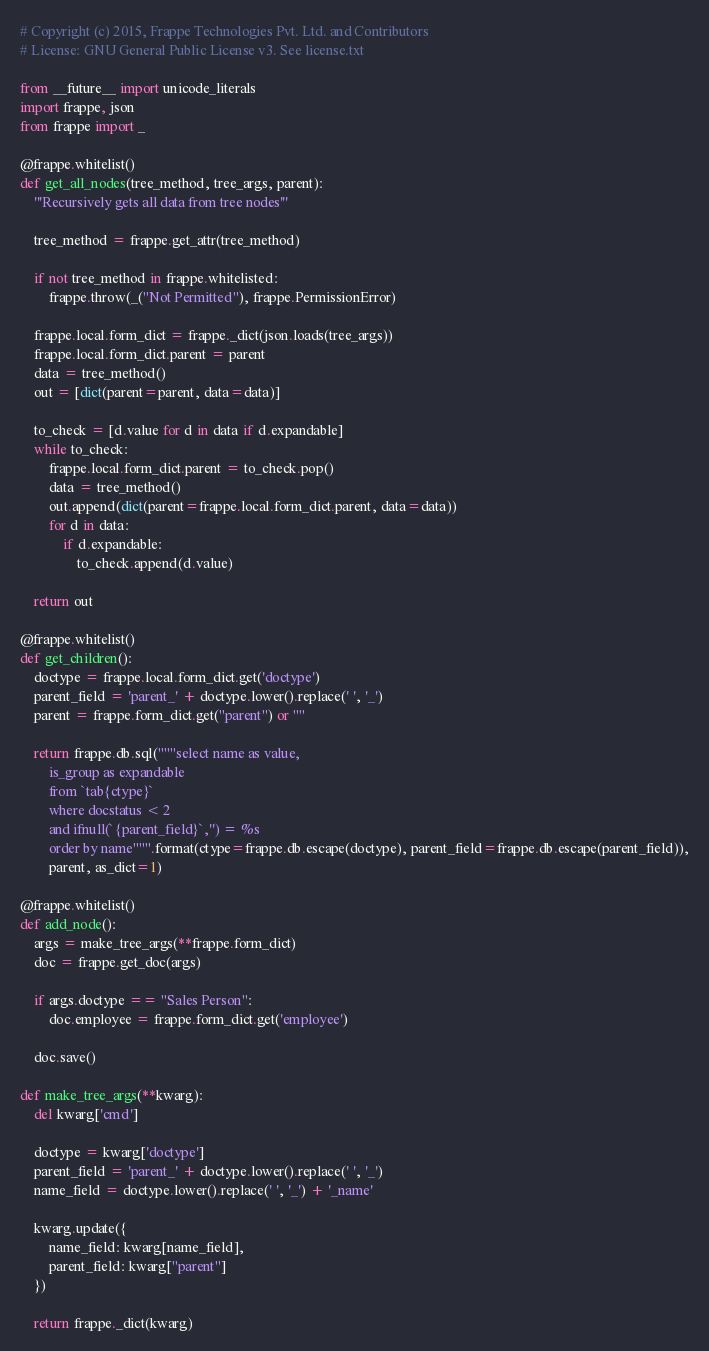<code> <loc_0><loc_0><loc_500><loc_500><_Python_># Copyright (c) 2015, Frappe Technologies Pvt. Ltd. and Contributors
# License: GNU General Public License v3. See license.txt

from __future__ import unicode_literals
import frappe, json
from frappe import _

@frappe.whitelist()
def get_all_nodes(tree_method, tree_args, parent):
	'''Recursively gets all data from tree nodes'''

	tree_method = frappe.get_attr(tree_method)

	if not tree_method in frappe.whitelisted:
		frappe.throw(_("Not Permitted"), frappe.PermissionError)

	frappe.local.form_dict = frappe._dict(json.loads(tree_args))
	frappe.local.form_dict.parent = parent
	data = tree_method()
	out = [dict(parent=parent, data=data)]

	to_check = [d.value for d in data if d.expandable]
	while to_check:
		frappe.local.form_dict.parent = to_check.pop()
		data = tree_method()
		out.append(dict(parent=frappe.local.form_dict.parent, data=data))
		for d in data:
			if d.expandable:
				to_check.append(d.value)

	return out

@frappe.whitelist()
def get_children():
	doctype = frappe.local.form_dict.get('doctype')
	parent_field = 'parent_' + doctype.lower().replace(' ', '_')
	parent = frappe.form_dict.get("parent") or ""

	return frappe.db.sql("""select name as value,
		is_group as expandable
		from `tab{ctype}`
		where docstatus < 2
		and ifnull(`{parent_field}`,'') = %s
		order by name""".format(ctype=frappe.db.escape(doctype), parent_field=frappe.db.escape(parent_field)),
		parent, as_dict=1)

@frappe.whitelist()
def add_node():
	args = make_tree_args(**frappe.form_dict)
	doc = frappe.get_doc(args)

	if args.doctype == "Sales Person":
		doc.employee = frappe.form_dict.get('employee')

	doc.save()

def make_tree_args(**kwarg):
	del kwarg['cmd']
	
	doctype = kwarg['doctype']
	parent_field = 'parent_' + doctype.lower().replace(' ', '_')
	name_field = doctype.lower().replace(' ', '_') + '_name'
	
	kwarg.update({
		name_field: kwarg[name_field],
		parent_field: kwarg["parent"]
	})
	
	return frappe._dict(kwarg)
</code> 